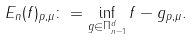<formula> <loc_0><loc_0><loc_500><loc_500>E _ { n } ( f ) _ { p , \mu } \colon = \inf _ { g \in \Pi _ { n - 1 } ^ { d } } \| f - g \| _ { p , \mu } .</formula> 